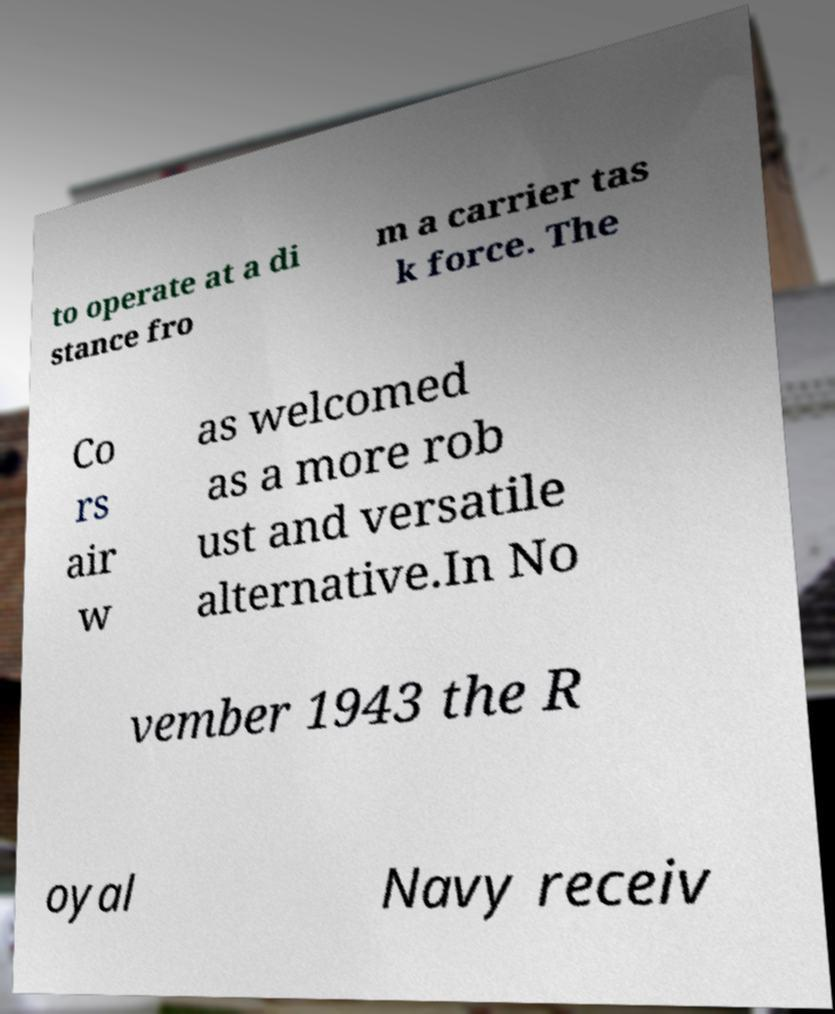Could you extract and type out the text from this image? to operate at a di stance fro m a carrier tas k force. The Co rs air w as welcomed as a more rob ust and versatile alternative.In No vember 1943 the R oyal Navy receiv 